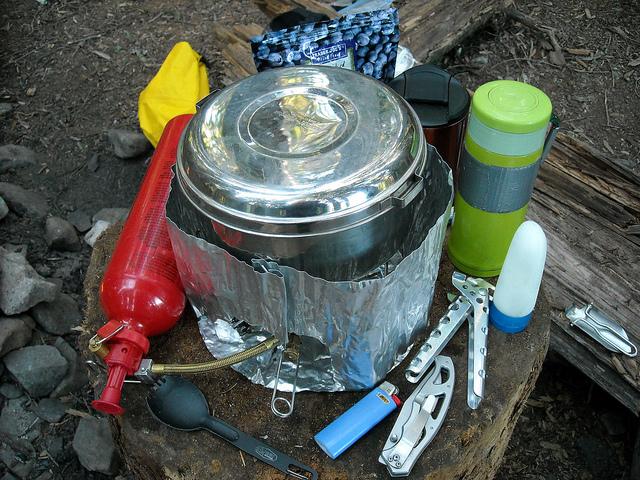What color is the spoon?
Be succinct. Black. Is there a lighter in the picture?
Be succinct. Yes. Is this item used for cooking?
Give a very brief answer. Yes. 